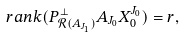Convert formula to latex. <formula><loc_0><loc_0><loc_500><loc_500>\ r a n k ( P _ { \mathcal { R } ( A _ { J _ { 1 } } ) } ^ { \perp } A _ { J _ { 0 } } X _ { 0 } ^ { J _ { 0 } } ) = r ,</formula> 